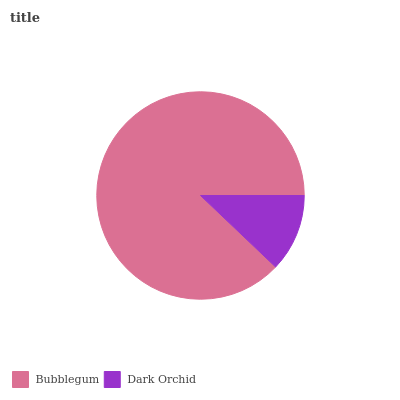Is Dark Orchid the minimum?
Answer yes or no. Yes. Is Bubblegum the maximum?
Answer yes or no. Yes. Is Dark Orchid the maximum?
Answer yes or no. No. Is Bubblegum greater than Dark Orchid?
Answer yes or no. Yes. Is Dark Orchid less than Bubblegum?
Answer yes or no. Yes. Is Dark Orchid greater than Bubblegum?
Answer yes or no. No. Is Bubblegum less than Dark Orchid?
Answer yes or no. No. Is Bubblegum the high median?
Answer yes or no. Yes. Is Dark Orchid the low median?
Answer yes or no. Yes. Is Dark Orchid the high median?
Answer yes or no. No. Is Bubblegum the low median?
Answer yes or no. No. 